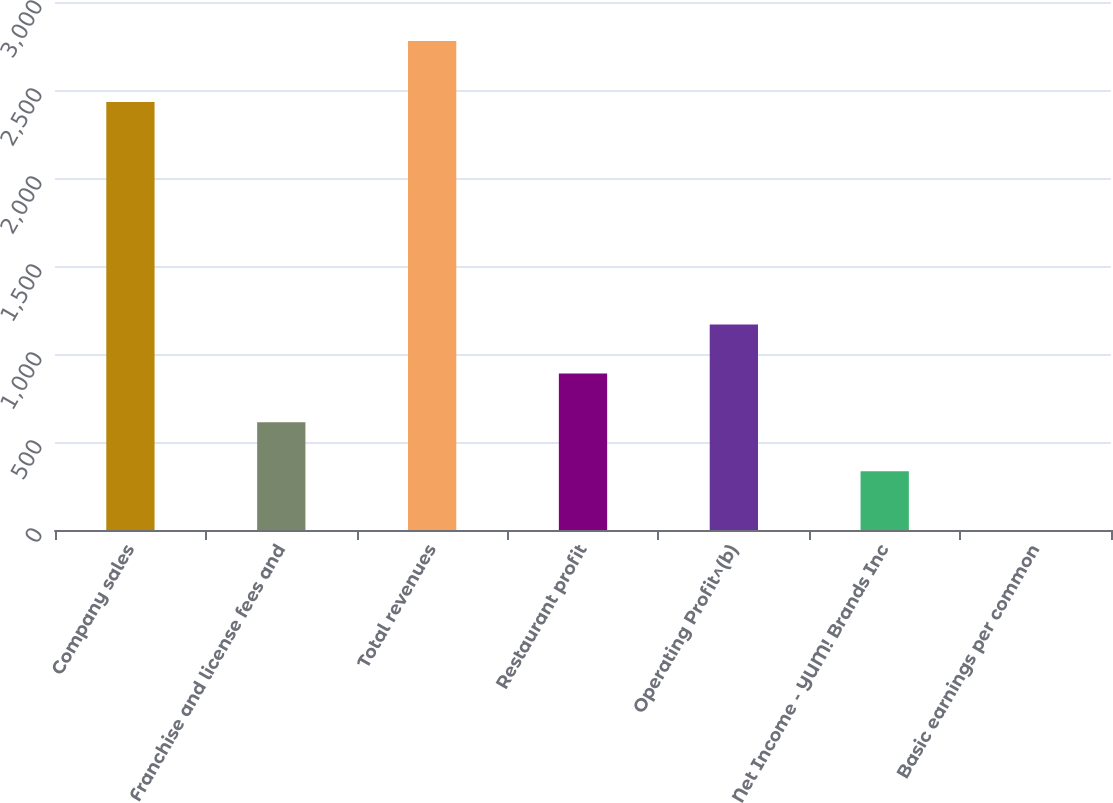Convert chart. <chart><loc_0><loc_0><loc_500><loc_500><bar_chart><fcel>Company sales<fcel>Franchise and license fees and<fcel>Total revenues<fcel>Restaurant profit<fcel>Operating Profit^(b)<fcel>Net Income - YUM! Brands Inc<fcel>Basic earnings per common<nl><fcel>2432<fcel>611.73<fcel>2778<fcel>889.46<fcel>1167.19<fcel>334<fcel>0.71<nl></chart> 